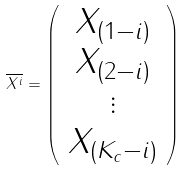Convert formula to latex. <formula><loc_0><loc_0><loc_500><loc_500>\overline { X ^ { i } } = \left ( \begin{array} { c } X _ { \left ( 1 - i \right ) } \\ X _ { \left ( 2 - i \right ) } \\ \vdots \\ X _ { \left ( K _ { c } - i \right ) } \end{array} \right )</formula> 